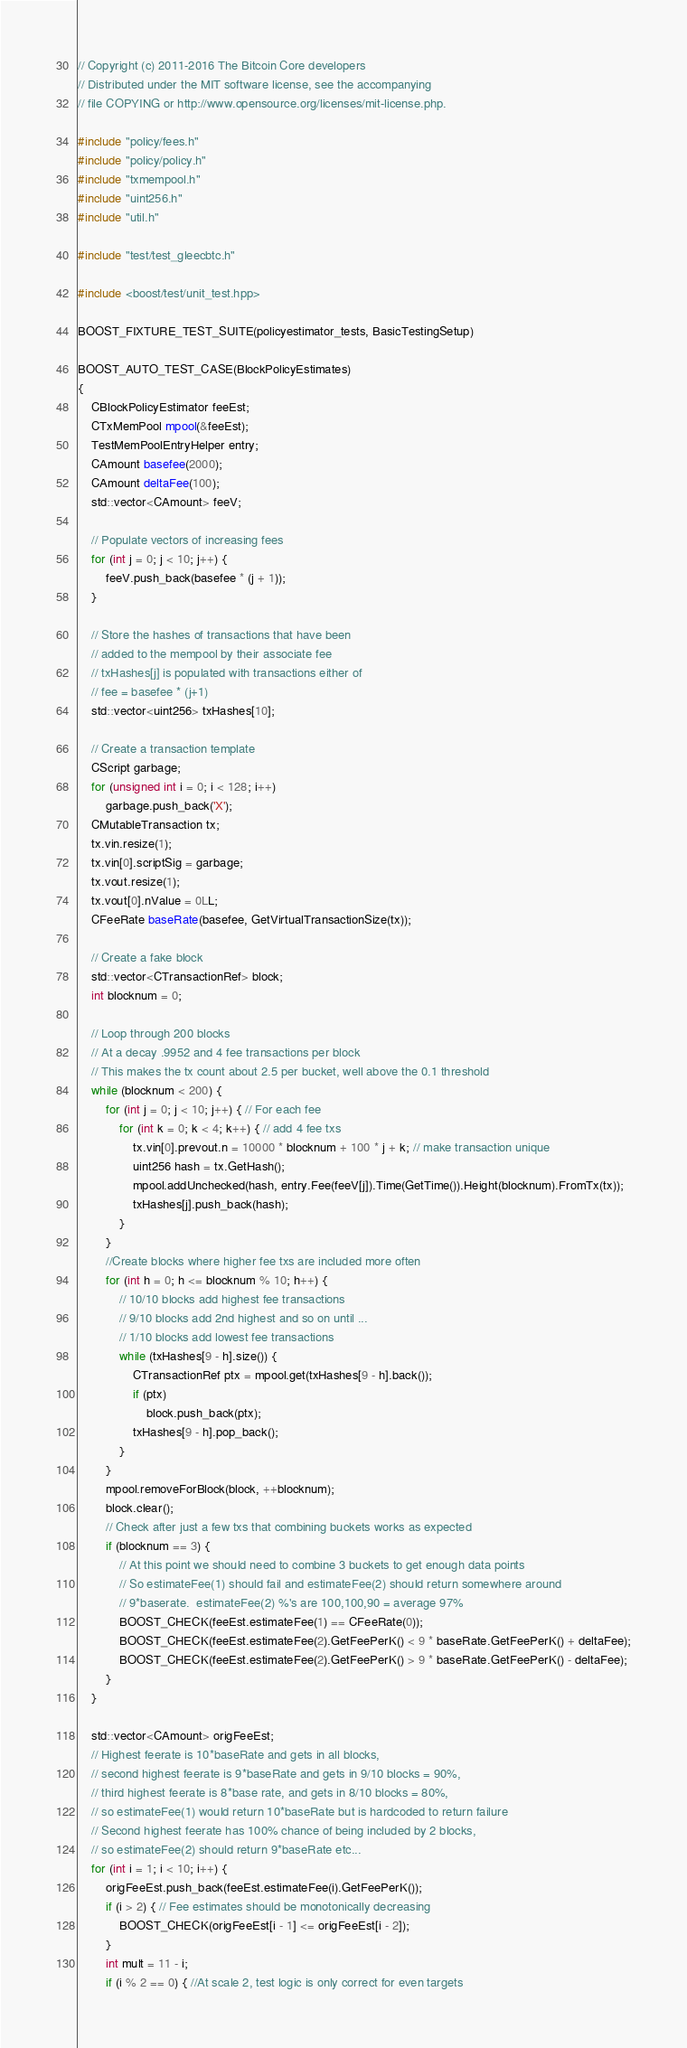Convert code to text. <code><loc_0><loc_0><loc_500><loc_500><_C++_>// Copyright (c) 2011-2016 The Bitcoin Core developers
// Distributed under the MIT software license, see the accompanying
// file COPYING or http://www.opensource.org/licenses/mit-license.php.

#include "policy/fees.h"
#include "policy/policy.h"
#include "txmempool.h"
#include "uint256.h"
#include "util.h"

#include "test/test_gleecbtc.h"

#include <boost/test/unit_test.hpp>

BOOST_FIXTURE_TEST_SUITE(policyestimator_tests, BasicTestingSetup)

BOOST_AUTO_TEST_CASE(BlockPolicyEstimates)
{
    CBlockPolicyEstimator feeEst;
    CTxMemPool mpool(&feeEst);
    TestMemPoolEntryHelper entry;
    CAmount basefee(2000);
    CAmount deltaFee(100);
    std::vector<CAmount> feeV;

    // Populate vectors of increasing fees
    for (int j = 0; j < 10; j++) {
        feeV.push_back(basefee * (j + 1));
    }

    // Store the hashes of transactions that have been
    // added to the mempool by their associate fee
    // txHashes[j] is populated with transactions either of
    // fee = basefee * (j+1)
    std::vector<uint256> txHashes[10];

    // Create a transaction template
    CScript garbage;
    for (unsigned int i = 0; i < 128; i++)
        garbage.push_back('X');
    CMutableTransaction tx;
    tx.vin.resize(1);
    tx.vin[0].scriptSig = garbage;
    tx.vout.resize(1);
    tx.vout[0].nValue = 0LL;
    CFeeRate baseRate(basefee, GetVirtualTransactionSize(tx));

    // Create a fake block
    std::vector<CTransactionRef> block;
    int blocknum = 0;

    // Loop through 200 blocks
    // At a decay .9952 and 4 fee transactions per block
    // This makes the tx count about 2.5 per bucket, well above the 0.1 threshold
    while (blocknum < 200) {
        for (int j = 0; j < 10; j++) { // For each fee
            for (int k = 0; k < 4; k++) { // add 4 fee txs
                tx.vin[0].prevout.n = 10000 * blocknum + 100 * j + k; // make transaction unique
                uint256 hash = tx.GetHash();
                mpool.addUnchecked(hash, entry.Fee(feeV[j]).Time(GetTime()).Height(blocknum).FromTx(tx));
                txHashes[j].push_back(hash);
            }
        }
        //Create blocks where higher fee txs are included more often
        for (int h = 0; h <= blocknum % 10; h++) {
            // 10/10 blocks add highest fee transactions
            // 9/10 blocks add 2nd highest and so on until ...
            // 1/10 blocks add lowest fee transactions
            while (txHashes[9 - h].size()) {
                CTransactionRef ptx = mpool.get(txHashes[9 - h].back());
                if (ptx)
                    block.push_back(ptx);
                txHashes[9 - h].pop_back();
            }
        }
        mpool.removeForBlock(block, ++blocknum);
        block.clear();
        // Check after just a few txs that combining buckets works as expected
        if (blocknum == 3) {
            // At this point we should need to combine 3 buckets to get enough data points
            // So estimateFee(1) should fail and estimateFee(2) should return somewhere around
            // 9*baserate.  estimateFee(2) %'s are 100,100,90 = average 97%
            BOOST_CHECK(feeEst.estimateFee(1) == CFeeRate(0));
            BOOST_CHECK(feeEst.estimateFee(2).GetFeePerK() < 9 * baseRate.GetFeePerK() + deltaFee);
            BOOST_CHECK(feeEst.estimateFee(2).GetFeePerK() > 9 * baseRate.GetFeePerK() - deltaFee);
        }
    }

    std::vector<CAmount> origFeeEst;
    // Highest feerate is 10*baseRate and gets in all blocks,
    // second highest feerate is 9*baseRate and gets in 9/10 blocks = 90%,
    // third highest feerate is 8*base rate, and gets in 8/10 blocks = 80%,
    // so estimateFee(1) would return 10*baseRate but is hardcoded to return failure
    // Second highest feerate has 100% chance of being included by 2 blocks,
    // so estimateFee(2) should return 9*baseRate etc...
    for (int i = 1; i < 10; i++) {
        origFeeEst.push_back(feeEst.estimateFee(i).GetFeePerK());
        if (i > 2) { // Fee estimates should be monotonically decreasing
            BOOST_CHECK(origFeeEst[i - 1] <= origFeeEst[i - 2]);
        }
        int mult = 11 - i;
        if (i % 2 == 0) { //At scale 2, test logic is only correct for even targets</code> 